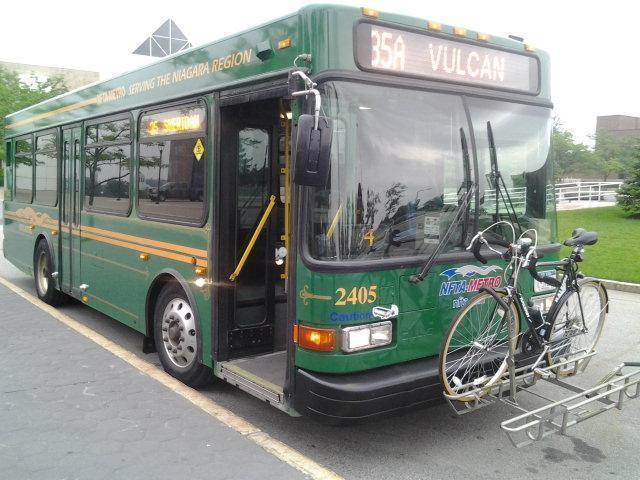How many bicycles do you see?
Give a very brief answer. 1. How many people are standing outside of the bus?
Give a very brief answer. 0. 